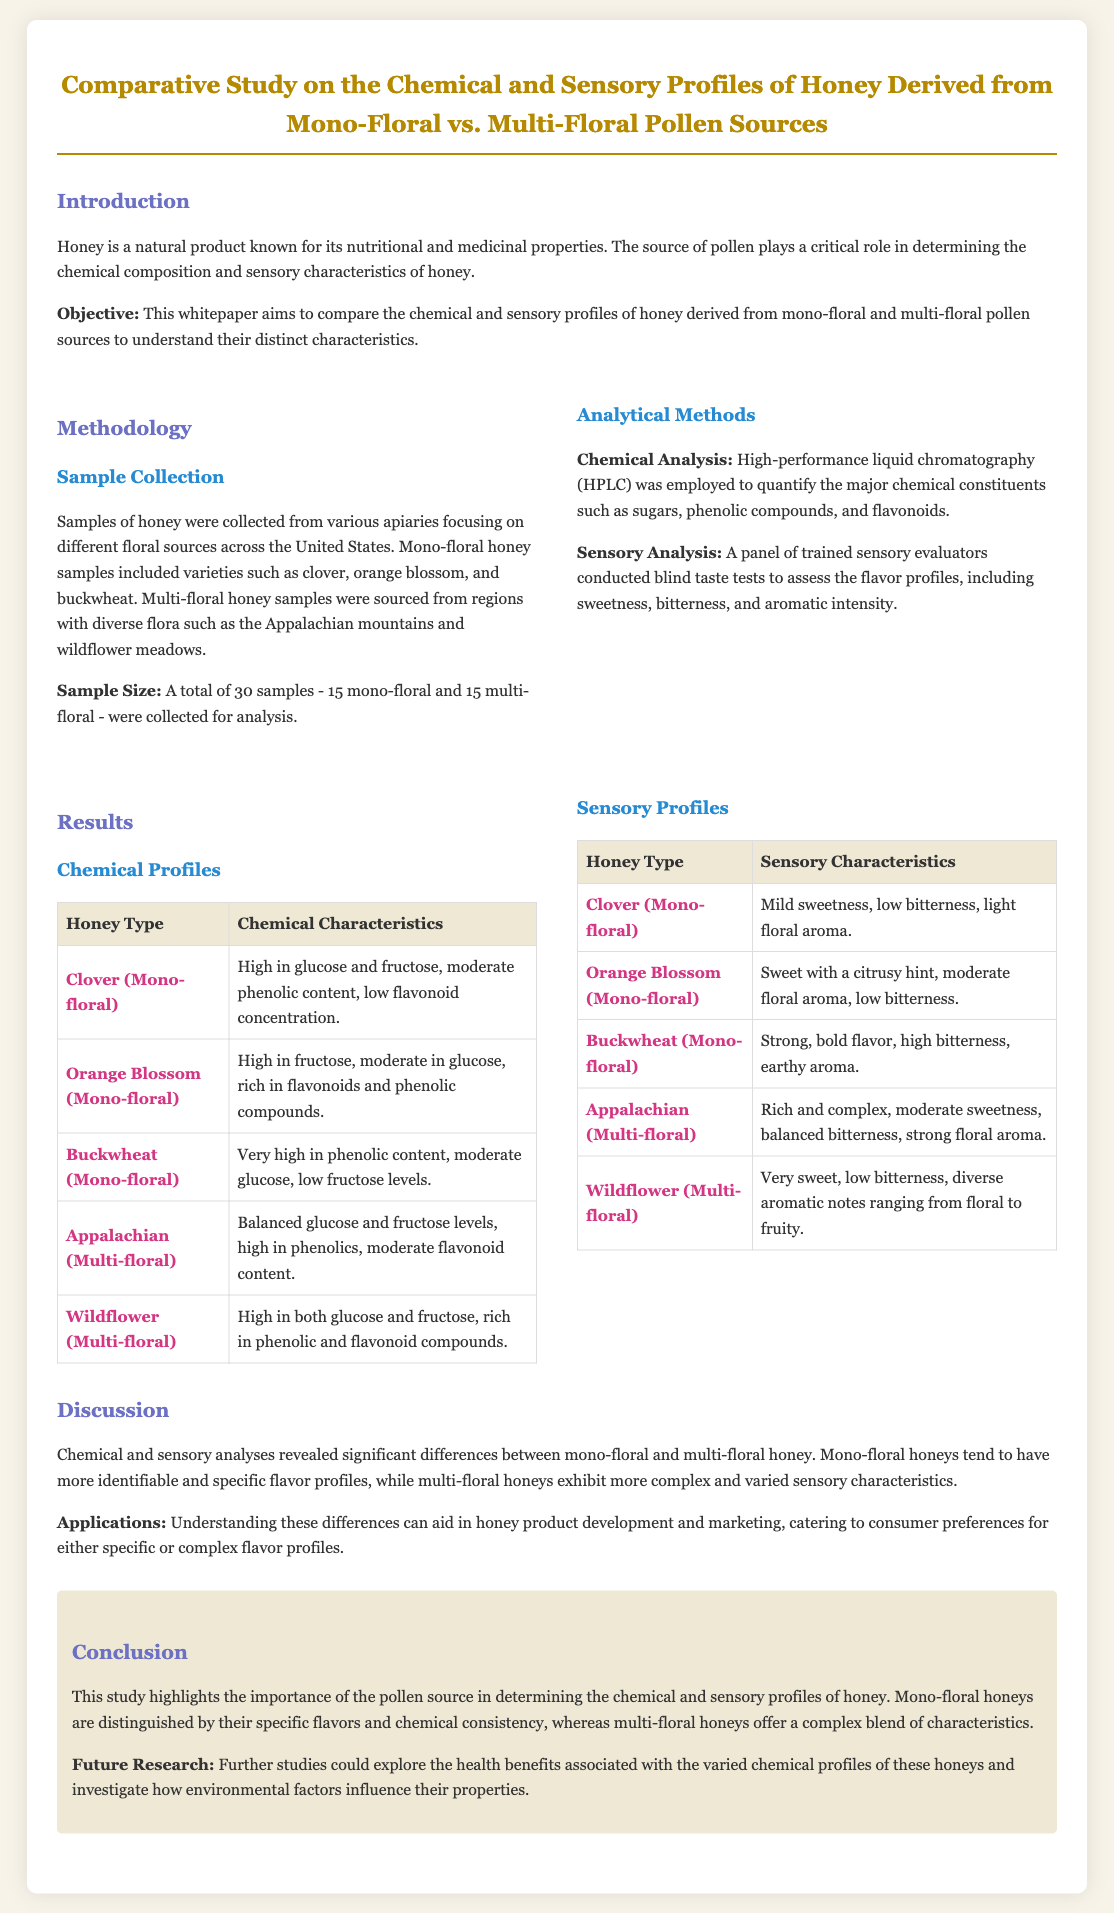what is the main objective of the study? The objective of the study is to compare the chemical and sensory profiles of honey derived from mono-floral and multi-floral pollen sources to understand their distinct characteristics.
Answer: to compare chemical and sensory profiles how many honey samples were collected for analysis? The total number of honey samples collected for analysis is mentioned in the document.
Answer: 30 samples which mono-floral honey has a very high phenolic content? The document specifies the characteristics of various mono-floral honey types, including those with high phenolic content.
Answer: Buckwheat what analytical method was used for chemical analysis? The study outlines which analytical method was employed to quantify major chemical constituents in honey.
Answer: High-performance liquid chromatography (HPLC) which multi-floral honey is described as having rich and complex sensory characteristics? The document provides descriptions of sensory characteristics for different honey types, specifying their profiles.
Answer: Appalachian what are the specific sensory characteristics of Wildflower honey? The document details the sensory characteristics of Wildflower honey, including sweetness and bitterness levels.
Answer: Very sweet, low bitterness, diverse aromatic notes ranging from floral to fruity how do mono-floral honeys differ from multi-floral honeys? The discussion section summarizes the differences in flavor and sensory characteristics between the two types of honey.
Answer: More identifiable and specific flavor profiles what future research could be conducted according to the conclusion? The conclusion section suggests exploring specific aspects related to honey in future studies.
Answer: Health benefits associated with chemical profiles 